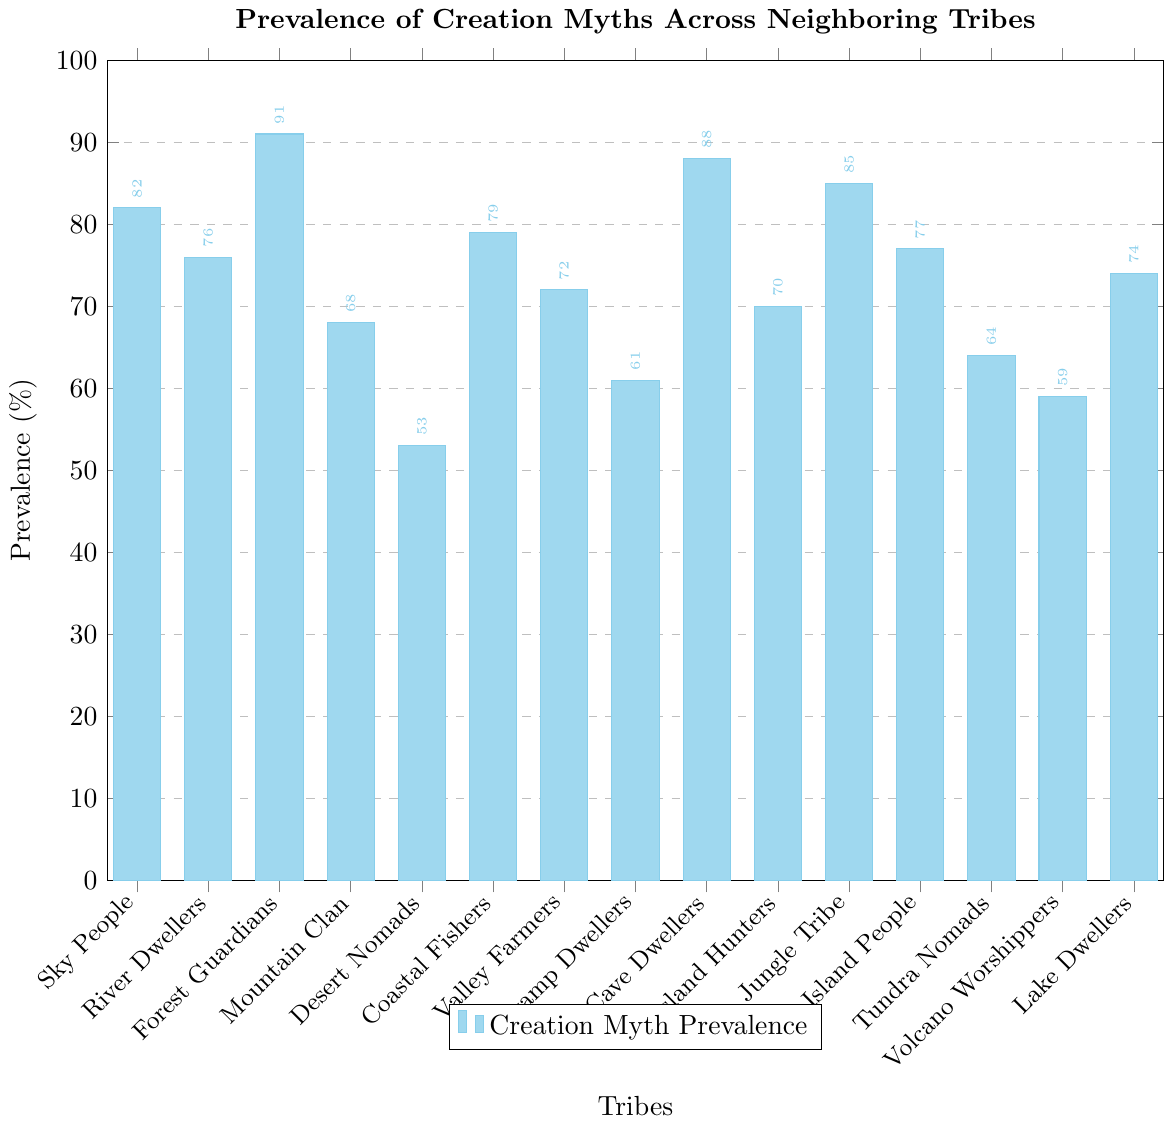What's the most prevalent creation myth among the tribes? To find the most prevalent creation myth, look for the bar with the greatest height, which represents the highest percentage value. The Forest Guardians have the highest prevalence with a value of 91%.
Answer: Forest Guardians Which tribe has the lowest prevalence of creation myths? Look for the shortest bar, indicating the smallest percentage. The Desert Nomads have the shortest bar with a prevalence of 53%.
Answer: Desert Nomads What is the average prevalence of creation myths for the Sky People, River Dwellers, and Coastal Fishers? Sum the prevalence values (82 for Sky People, 76 for River Dwellers, 79 for Coastal Fishers) and divide by the number of tribes (3). So, (82 + 76 + 79) / 3 = 237 / 3 = 79%.
Answer: 79% How many tribes have a prevalence greater than 80%? Count the number of bars exceeding the 80% mark: Sky People (82%), Forest Guardians (91%), Cave Dwellers (88%), and Jungle Tribe (85%). This amounts to 4 tribes.
Answer: 4 Which tribe has a comparable prevalence to Valley Farmers? Look for bars close to 72% in height. Coastal Fishers have a prevalence of 79% and Island People have 77%, which are relatively close to Valley Farmers (72%).
Answer: Coastal Fishers, Island People What is the difference in prevalence between the tribe with the highest value and the tribe with the lowest value? Subtract the lowest prevalence (Desert Nomads, 53%) from the highest prevalence (Forest Guardians, 91%): 91% - 53% = 38%.
Answer: 38% Which group of tribes has a higher combined prevalence: Mountain Clan, Lake Dwellers, and Tundra Nomads, or Swamp Dwellers, Grassland Hunters, and Volcano Worshippers? Calculate the sums: Mountain Clan (68%), Lake Dwellers (74%), and Tundra Nomads (64%) sum to 206%. Swamp Dwellers (61%), Grassland Hunters (70%), and Volcano Worshippers (59%) sum to 190%. So, the first group has a higher combined prevalence.
Answer: Mountain Clan, Lake Dwellers, and Tundra Nomads What is the median prevalence of all tribes? Arrange the percentages in ascending order and find the middle value: [53, 59, 61, 64, 68, 70, 72, 74, 76, 77, 79, 82, 85, 88, 91]. The middle value (median) is 74%.
Answer: 74% Is the prevalence of creation myths in the Jungle Tribe greater than that in the Grassland Hunters? Compare their values from the chart: Jungle Tribe has 85%, which is greater than Grassland Hunters' 70%.
Answer: Yes Which color represents the bar for the Sky People? Identify the color of the bar for the Sky People by looking at the chart's legend and color coding, it's represented by a sky-blue shade.
Answer: Sky-blue 